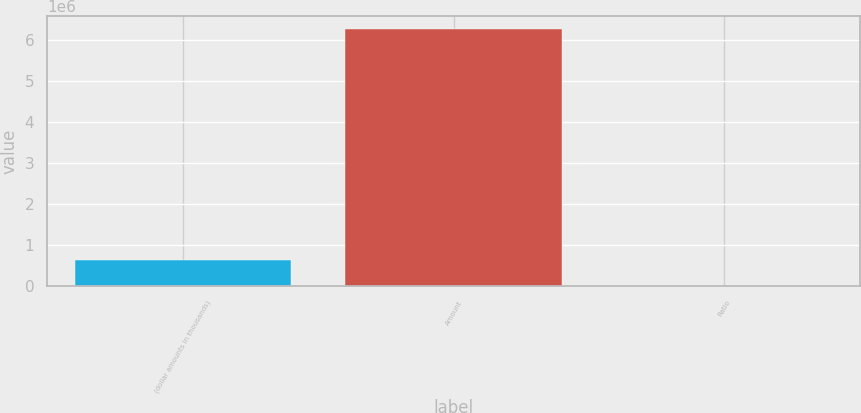Convert chart to OTSL. <chart><loc_0><loc_0><loc_500><loc_500><bar_chart><fcel>(dollar amounts in thousands)<fcel>Amount<fcel>Ratio<nl><fcel>626600<fcel>6.2659e+06<fcel>11.5<nl></chart> 